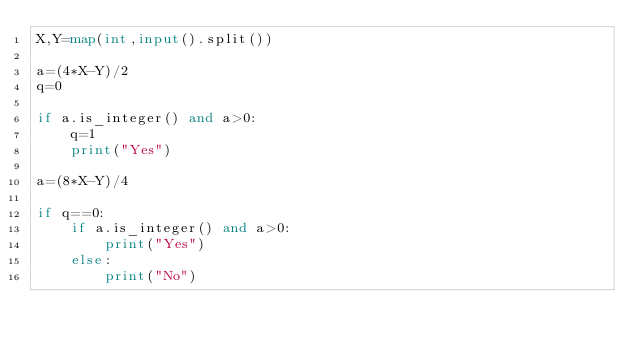Convert code to text. <code><loc_0><loc_0><loc_500><loc_500><_Python_>X,Y=map(int,input().split())

a=(4*X-Y)/2
q=0

if a.is_integer() and a>0:
    q=1
    print("Yes")

a=(8*X-Y)/4

if q==0:
    if a.is_integer() and a>0:
        print("Yes")
    else:
        print("No")</code> 